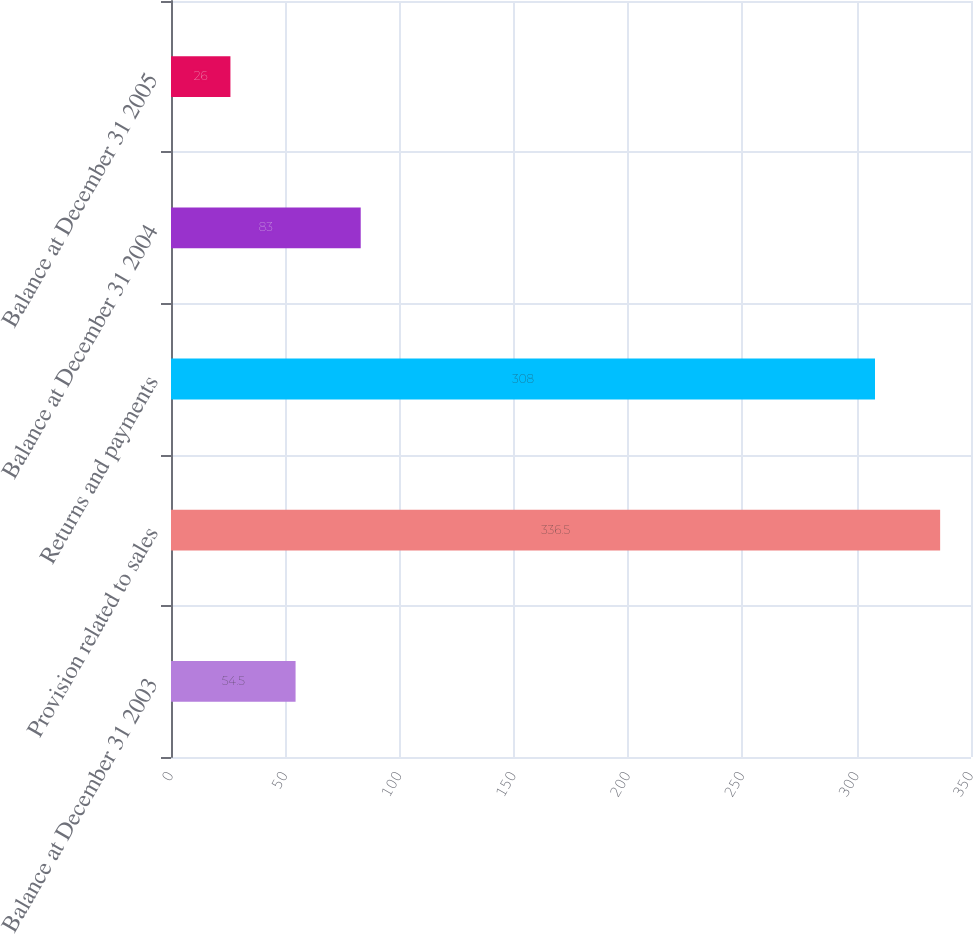Convert chart. <chart><loc_0><loc_0><loc_500><loc_500><bar_chart><fcel>Balance at December 31 2003<fcel>Provision related to sales<fcel>Returns and payments<fcel>Balance at December 31 2004<fcel>Balance at December 31 2005<nl><fcel>54.5<fcel>336.5<fcel>308<fcel>83<fcel>26<nl></chart> 